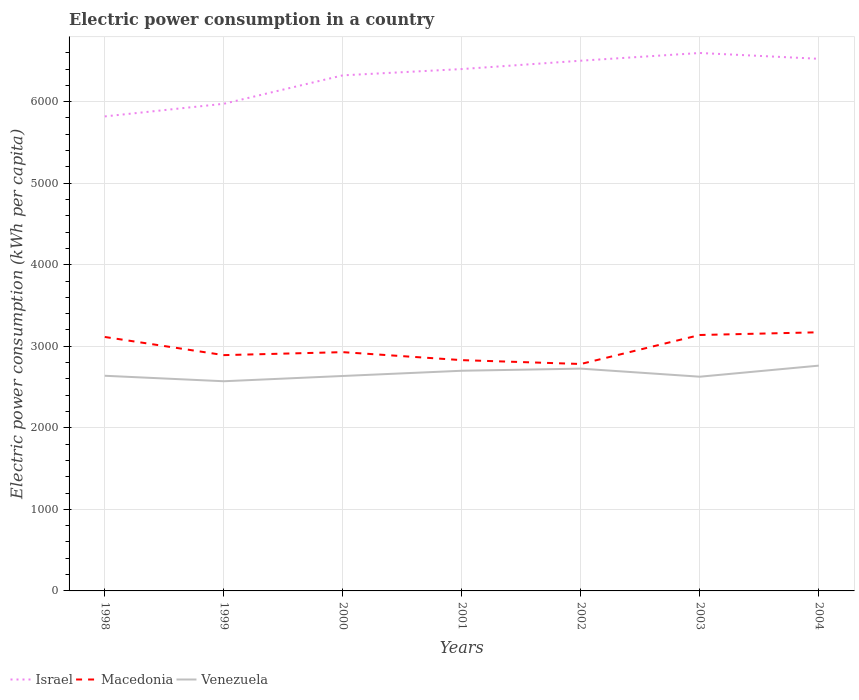How many different coloured lines are there?
Offer a terse response. 3. Is the number of lines equal to the number of legend labels?
Ensure brevity in your answer.  Yes. Across all years, what is the maximum electric power consumption in in Macedonia?
Ensure brevity in your answer.  2783.05. In which year was the electric power consumption in in Venezuela maximum?
Your answer should be very brief. 1999. What is the total electric power consumption in in Israel in the graph?
Provide a succinct answer. -274.2. What is the difference between the highest and the second highest electric power consumption in in Israel?
Make the answer very short. 777.85. What is the difference between the highest and the lowest electric power consumption in in Venezuela?
Your response must be concise. 3. Is the electric power consumption in in Macedonia strictly greater than the electric power consumption in in Venezuela over the years?
Your response must be concise. No. How many years are there in the graph?
Keep it short and to the point. 7. What is the difference between two consecutive major ticks on the Y-axis?
Offer a very short reply. 1000. Are the values on the major ticks of Y-axis written in scientific E-notation?
Provide a succinct answer. No. Does the graph contain any zero values?
Your response must be concise. No. How are the legend labels stacked?
Your answer should be very brief. Horizontal. What is the title of the graph?
Ensure brevity in your answer.  Electric power consumption in a country. What is the label or title of the Y-axis?
Your answer should be very brief. Electric power consumption (kWh per capita). What is the Electric power consumption (kWh per capita) of Israel in 1998?
Your response must be concise. 5819.46. What is the Electric power consumption (kWh per capita) in Macedonia in 1998?
Provide a short and direct response. 3114.54. What is the Electric power consumption (kWh per capita) in Venezuela in 1998?
Your response must be concise. 2638.75. What is the Electric power consumption (kWh per capita) in Israel in 1999?
Provide a succinct answer. 5974.37. What is the Electric power consumption (kWh per capita) of Macedonia in 1999?
Give a very brief answer. 2891.92. What is the Electric power consumption (kWh per capita) of Venezuela in 1999?
Offer a very short reply. 2571.54. What is the Electric power consumption (kWh per capita) of Israel in 2000?
Make the answer very short. 6323.1. What is the Electric power consumption (kWh per capita) of Macedonia in 2000?
Offer a very short reply. 2928.36. What is the Electric power consumption (kWh per capita) in Venezuela in 2000?
Give a very brief answer. 2636.12. What is the Electric power consumption (kWh per capita) of Israel in 2001?
Offer a terse response. 6400.22. What is the Electric power consumption (kWh per capita) in Macedonia in 2001?
Keep it short and to the point. 2830.45. What is the Electric power consumption (kWh per capita) of Venezuela in 2001?
Offer a terse response. 2700.22. What is the Electric power consumption (kWh per capita) in Israel in 2002?
Make the answer very short. 6502.74. What is the Electric power consumption (kWh per capita) of Macedonia in 2002?
Make the answer very short. 2783.05. What is the Electric power consumption (kWh per capita) of Venezuela in 2002?
Ensure brevity in your answer.  2726.12. What is the Electric power consumption (kWh per capita) in Israel in 2003?
Your response must be concise. 6597.31. What is the Electric power consumption (kWh per capita) of Macedonia in 2003?
Provide a succinct answer. 3138.68. What is the Electric power consumption (kWh per capita) of Venezuela in 2003?
Your answer should be compact. 2627.24. What is the Electric power consumption (kWh per capita) of Israel in 2004?
Make the answer very short. 6525.92. What is the Electric power consumption (kWh per capita) in Macedonia in 2004?
Ensure brevity in your answer.  3172.03. What is the Electric power consumption (kWh per capita) of Venezuela in 2004?
Your response must be concise. 2762.93. Across all years, what is the maximum Electric power consumption (kWh per capita) in Israel?
Offer a terse response. 6597.31. Across all years, what is the maximum Electric power consumption (kWh per capita) of Macedonia?
Make the answer very short. 3172.03. Across all years, what is the maximum Electric power consumption (kWh per capita) in Venezuela?
Provide a short and direct response. 2762.93. Across all years, what is the minimum Electric power consumption (kWh per capita) of Israel?
Your response must be concise. 5819.46. Across all years, what is the minimum Electric power consumption (kWh per capita) of Macedonia?
Offer a terse response. 2783.05. Across all years, what is the minimum Electric power consumption (kWh per capita) in Venezuela?
Keep it short and to the point. 2571.54. What is the total Electric power consumption (kWh per capita) of Israel in the graph?
Offer a terse response. 4.41e+04. What is the total Electric power consumption (kWh per capita) in Macedonia in the graph?
Give a very brief answer. 2.09e+04. What is the total Electric power consumption (kWh per capita) of Venezuela in the graph?
Make the answer very short. 1.87e+04. What is the difference between the Electric power consumption (kWh per capita) of Israel in 1998 and that in 1999?
Offer a very short reply. -154.91. What is the difference between the Electric power consumption (kWh per capita) of Macedonia in 1998 and that in 1999?
Give a very brief answer. 222.62. What is the difference between the Electric power consumption (kWh per capita) in Venezuela in 1998 and that in 1999?
Your answer should be very brief. 67.21. What is the difference between the Electric power consumption (kWh per capita) in Israel in 1998 and that in 2000?
Your answer should be very brief. -503.64. What is the difference between the Electric power consumption (kWh per capita) in Macedonia in 1998 and that in 2000?
Provide a short and direct response. 186.18. What is the difference between the Electric power consumption (kWh per capita) in Venezuela in 1998 and that in 2000?
Ensure brevity in your answer.  2.63. What is the difference between the Electric power consumption (kWh per capita) in Israel in 1998 and that in 2001?
Give a very brief answer. -580.76. What is the difference between the Electric power consumption (kWh per capita) in Macedonia in 1998 and that in 2001?
Offer a terse response. 284.09. What is the difference between the Electric power consumption (kWh per capita) of Venezuela in 1998 and that in 2001?
Give a very brief answer. -61.47. What is the difference between the Electric power consumption (kWh per capita) of Israel in 1998 and that in 2002?
Your answer should be compact. -683.28. What is the difference between the Electric power consumption (kWh per capita) in Macedonia in 1998 and that in 2002?
Your answer should be very brief. 331.48. What is the difference between the Electric power consumption (kWh per capita) in Venezuela in 1998 and that in 2002?
Keep it short and to the point. -87.37. What is the difference between the Electric power consumption (kWh per capita) in Israel in 1998 and that in 2003?
Offer a very short reply. -777.85. What is the difference between the Electric power consumption (kWh per capita) in Macedonia in 1998 and that in 2003?
Your answer should be very brief. -24.14. What is the difference between the Electric power consumption (kWh per capita) in Venezuela in 1998 and that in 2003?
Ensure brevity in your answer.  11.51. What is the difference between the Electric power consumption (kWh per capita) in Israel in 1998 and that in 2004?
Provide a succinct answer. -706.46. What is the difference between the Electric power consumption (kWh per capita) in Macedonia in 1998 and that in 2004?
Provide a short and direct response. -57.49. What is the difference between the Electric power consumption (kWh per capita) of Venezuela in 1998 and that in 2004?
Ensure brevity in your answer.  -124.18. What is the difference between the Electric power consumption (kWh per capita) of Israel in 1999 and that in 2000?
Your response must be concise. -348.74. What is the difference between the Electric power consumption (kWh per capita) in Macedonia in 1999 and that in 2000?
Your answer should be compact. -36.43. What is the difference between the Electric power consumption (kWh per capita) in Venezuela in 1999 and that in 2000?
Ensure brevity in your answer.  -64.58. What is the difference between the Electric power consumption (kWh per capita) in Israel in 1999 and that in 2001?
Keep it short and to the point. -425.85. What is the difference between the Electric power consumption (kWh per capita) of Macedonia in 1999 and that in 2001?
Your answer should be very brief. 61.47. What is the difference between the Electric power consumption (kWh per capita) in Venezuela in 1999 and that in 2001?
Offer a very short reply. -128.68. What is the difference between the Electric power consumption (kWh per capita) of Israel in 1999 and that in 2002?
Provide a short and direct response. -528.37. What is the difference between the Electric power consumption (kWh per capita) of Macedonia in 1999 and that in 2002?
Give a very brief answer. 108.87. What is the difference between the Electric power consumption (kWh per capita) of Venezuela in 1999 and that in 2002?
Your response must be concise. -154.58. What is the difference between the Electric power consumption (kWh per capita) of Israel in 1999 and that in 2003?
Provide a short and direct response. -622.94. What is the difference between the Electric power consumption (kWh per capita) of Macedonia in 1999 and that in 2003?
Your answer should be very brief. -246.76. What is the difference between the Electric power consumption (kWh per capita) of Venezuela in 1999 and that in 2003?
Provide a succinct answer. -55.7. What is the difference between the Electric power consumption (kWh per capita) in Israel in 1999 and that in 2004?
Ensure brevity in your answer.  -551.55. What is the difference between the Electric power consumption (kWh per capita) in Macedonia in 1999 and that in 2004?
Offer a very short reply. -280.1. What is the difference between the Electric power consumption (kWh per capita) of Venezuela in 1999 and that in 2004?
Give a very brief answer. -191.39. What is the difference between the Electric power consumption (kWh per capita) of Israel in 2000 and that in 2001?
Make the answer very short. -77.11. What is the difference between the Electric power consumption (kWh per capita) in Macedonia in 2000 and that in 2001?
Make the answer very short. 97.9. What is the difference between the Electric power consumption (kWh per capita) in Venezuela in 2000 and that in 2001?
Make the answer very short. -64.1. What is the difference between the Electric power consumption (kWh per capita) in Israel in 2000 and that in 2002?
Make the answer very short. -179.64. What is the difference between the Electric power consumption (kWh per capita) of Macedonia in 2000 and that in 2002?
Keep it short and to the point. 145.3. What is the difference between the Electric power consumption (kWh per capita) in Venezuela in 2000 and that in 2002?
Keep it short and to the point. -90. What is the difference between the Electric power consumption (kWh per capita) of Israel in 2000 and that in 2003?
Ensure brevity in your answer.  -274.2. What is the difference between the Electric power consumption (kWh per capita) in Macedonia in 2000 and that in 2003?
Offer a terse response. -210.33. What is the difference between the Electric power consumption (kWh per capita) in Venezuela in 2000 and that in 2003?
Your answer should be very brief. 8.88. What is the difference between the Electric power consumption (kWh per capita) of Israel in 2000 and that in 2004?
Offer a very short reply. -202.82. What is the difference between the Electric power consumption (kWh per capita) in Macedonia in 2000 and that in 2004?
Give a very brief answer. -243.67. What is the difference between the Electric power consumption (kWh per capita) in Venezuela in 2000 and that in 2004?
Your response must be concise. -126.81. What is the difference between the Electric power consumption (kWh per capita) of Israel in 2001 and that in 2002?
Your answer should be very brief. -102.52. What is the difference between the Electric power consumption (kWh per capita) of Macedonia in 2001 and that in 2002?
Offer a terse response. 47.4. What is the difference between the Electric power consumption (kWh per capita) in Venezuela in 2001 and that in 2002?
Your answer should be very brief. -25.9. What is the difference between the Electric power consumption (kWh per capita) in Israel in 2001 and that in 2003?
Your answer should be compact. -197.09. What is the difference between the Electric power consumption (kWh per capita) of Macedonia in 2001 and that in 2003?
Offer a very short reply. -308.23. What is the difference between the Electric power consumption (kWh per capita) of Venezuela in 2001 and that in 2003?
Your response must be concise. 72.98. What is the difference between the Electric power consumption (kWh per capita) of Israel in 2001 and that in 2004?
Make the answer very short. -125.7. What is the difference between the Electric power consumption (kWh per capita) of Macedonia in 2001 and that in 2004?
Ensure brevity in your answer.  -341.57. What is the difference between the Electric power consumption (kWh per capita) of Venezuela in 2001 and that in 2004?
Ensure brevity in your answer.  -62.71. What is the difference between the Electric power consumption (kWh per capita) in Israel in 2002 and that in 2003?
Give a very brief answer. -94.57. What is the difference between the Electric power consumption (kWh per capita) in Macedonia in 2002 and that in 2003?
Offer a terse response. -355.63. What is the difference between the Electric power consumption (kWh per capita) of Venezuela in 2002 and that in 2003?
Offer a very short reply. 98.88. What is the difference between the Electric power consumption (kWh per capita) of Israel in 2002 and that in 2004?
Provide a short and direct response. -23.18. What is the difference between the Electric power consumption (kWh per capita) in Macedonia in 2002 and that in 2004?
Your answer should be very brief. -388.97. What is the difference between the Electric power consumption (kWh per capita) in Venezuela in 2002 and that in 2004?
Give a very brief answer. -36.81. What is the difference between the Electric power consumption (kWh per capita) of Israel in 2003 and that in 2004?
Give a very brief answer. 71.38. What is the difference between the Electric power consumption (kWh per capita) in Macedonia in 2003 and that in 2004?
Ensure brevity in your answer.  -33.34. What is the difference between the Electric power consumption (kWh per capita) in Venezuela in 2003 and that in 2004?
Make the answer very short. -135.69. What is the difference between the Electric power consumption (kWh per capita) of Israel in 1998 and the Electric power consumption (kWh per capita) of Macedonia in 1999?
Provide a short and direct response. 2927.54. What is the difference between the Electric power consumption (kWh per capita) in Israel in 1998 and the Electric power consumption (kWh per capita) in Venezuela in 1999?
Your response must be concise. 3247.92. What is the difference between the Electric power consumption (kWh per capita) in Macedonia in 1998 and the Electric power consumption (kWh per capita) in Venezuela in 1999?
Your answer should be compact. 543. What is the difference between the Electric power consumption (kWh per capita) of Israel in 1998 and the Electric power consumption (kWh per capita) of Macedonia in 2000?
Make the answer very short. 2891.11. What is the difference between the Electric power consumption (kWh per capita) in Israel in 1998 and the Electric power consumption (kWh per capita) in Venezuela in 2000?
Your answer should be compact. 3183.35. What is the difference between the Electric power consumption (kWh per capita) of Macedonia in 1998 and the Electric power consumption (kWh per capita) of Venezuela in 2000?
Provide a succinct answer. 478.42. What is the difference between the Electric power consumption (kWh per capita) in Israel in 1998 and the Electric power consumption (kWh per capita) in Macedonia in 2001?
Make the answer very short. 2989.01. What is the difference between the Electric power consumption (kWh per capita) of Israel in 1998 and the Electric power consumption (kWh per capita) of Venezuela in 2001?
Offer a very short reply. 3119.24. What is the difference between the Electric power consumption (kWh per capita) of Macedonia in 1998 and the Electric power consumption (kWh per capita) of Venezuela in 2001?
Ensure brevity in your answer.  414.32. What is the difference between the Electric power consumption (kWh per capita) in Israel in 1998 and the Electric power consumption (kWh per capita) in Macedonia in 2002?
Your answer should be very brief. 3036.41. What is the difference between the Electric power consumption (kWh per capita) in Israel in 1998 and the Electric power consumption (kWh per capita) in Venezuela in 2002?
Offer a very short reply. 3093.35. What is the difference between the Electric power consumption (kWh per capita) of Macedonia in 1998 and the Electric power consumption (kWh per capita) of Venezuela in 2002?
Your answer should be compact. 388.42. What is the difference between the Electric power consumption (kWh per capita) in Israel in 1998 and the Electric power consumption (kWh per capita) in Macedonia in 2003?
Provide a short and direct response. 2680.78. What is the difference between the Electric power consumption (kWh per capita) in Israel in 1998 and the Electric power consumption (kWh per capita) in Venezuela in 2003?
Ensure brevity in your answer.  3192.22. What is the difference between the Electric power consumption (kWh per capita) in Macedonia in 1998 and the Electric power consumption (kWh per capita) in Venezuela in 2003?
Provide a short and direct response. 487.3. What is the difference between the Electric power consumption (kWh per capita) of Israel in 1998 and the Electric power consumption (kWh per capita) of Macedonia in 2004?
Your response must be concise. 2647.43. What is the difference between the Electric power consumption (kWh per capita) of Israel in 1998 and the Electric power consumption (kWh per capita) of Venezuela in 2004?
Provide a short and direct response. 3056.53. What is the difference between the Electric power consumption (kWh per capita) of Macedonia in 1998 and the Electric power consumption (kWh per capita) of Venezuela in 2004?
Ensure brevity in your answer.  351.61. What is the difference between the Electric power consumption (kWh per capita) of Israel in 1999 and the Electric power consumption (kWh per capita) of Macedonia in 2000?
Make the answer very short. 3046.01. What is the difference between the Electric power consumption (kWh per capita) in Israel in 1999 and the Electric power consumption (kWh per capita) in Venezuela in 2000?
Offer a very short reply. 3338.25. What is the difference between the Electric power consumption (kWh per capita) of Macedonia in 1999 and the Electric power consumption (kWh per capita) of Venezuela in 2000?
Provide a short and direct response. 255.81. What is the difference between the Electric power consumption (kWh per capita) in Israel in 1999 and the Electric power consumption (kWh per capita) in Macedonia in 2001?
Provide a succinct answer. 3143.91. What is the difference between the Electric power consumption (kWh per capita) in Israel in 1999 and the Electric power consumption (kWh per capita) in Venezuela in 2001?
Keep it short and to the point. 3274.15. What is the difference between the Electric power consumption (kWh per capita) in Macedonia in 1999 and the Electric power consumption (kWh per capita) in Venezuela in 2001?
Offer a very short reply. 191.71. What is the difference between the Electric power consumption (kWh per capita) of Israel in 1999 and the Electric power consumption (kWh per capita) of Macedonia in 2002?
Ensure brevity in your answer.  3191.31. What is the difference between the Electric power consumption (kWh per capita) of Israel in 1999 and the Electric power consumption (kWh per capita) of Venezuela in 2002?
Provide a short and direct response. 3248.25. What is the difference between the Electric power consumption (kWh per capita) in Macedonia in 1999 and the Electric power consumption (kWh per capita) in Venezuela in 2002?
Offer a very short reply. 165.81. What is the difference between the Electric power consumption (kWh per capita) in Israel in 1999 and the Electric power consumption (kWh per capita) in Macedonia in 2003?
Your answer should be compact. 2835.68. What is the difference between the Electric power consumption (kWh per capita) of Israel in 1999 and the Electric power consumption (kWh per capita) of Venezuela in 2003?
Ensure brevity in your answer.  3347.13. What is the difference between the Electric power consumption (kWh per capita) in Macedonia in 1999 and the Electric power consumption (kWh per capita) in Venezuela in 2003?
Ensure brevity in your answer.  264.68. What is the difference between the Electric power consumption (kWh per capita) in Israel in 1999 and the Electric power consumption (kWh per capita) in Macedonia in 2004?
Keep it short and to the point. 2802.34. What is the difference between the Electric power consumption (kWh per capita) in Israel in 1999 and the Electric power consumption (kWh per capita) in Venezuela in 2004?
Ensure brevity in your answer.  3211.44. What is the difference between the Electric power consumption (kWh per capita) of Macedonia in 1999 and the Electric power consumption (kWh per capita) of Venezuela in 2004?
Your response must be concise. 129. What is the difference between the Electric power consumption (kWh per capita) in Israel in 2000 and the Electric power consumption (kWh per capita) in Macedonia in 2001?
Keep it short and to the point. 3492.65. What is the difference between the Electric power consumption (kWh per capita) of Israel in 2000 and the Electric power consumption (kWh per capita) of Venezuela in 2001?
Make the answer very short. 3622.89. What is the difference between the Electric power consumption (kWh per capita) of Macedonia in 2000 and the Electric power consumption (kWh per capita) of Venezuela in 2001?
Offer a terse response. 228.14. What is the difference between the Electric power consumption (kWh per capita) in Israel in 2000 and the Electric power consumption (kWh per capita) in Macedonia in 2002?
Your answer should be very brief. 3540.05. What is the difference between the Electric power consumption (kWh per capita) of Israel in 2000 and the Electric power consumption (kWh per capita) of Venezuela in 2002?
Provide a succinct answer. 3596.99. What is the difference between the Electric power consumption (kWh per capita) in Macedonia in 2000 and the Electric power consumption (kWh per capita) in Venezuela in 2002?
Keep it short and to the point. 202.24. What is the difference between the Electric power consumption (kWh per capita) in Israel in 2000 and the Electric power consumption (kWh per capita) in Macedonia in 2003?
Provide a succinct answer. 3184.42. What is the difference between the Electric power consumption (kWh per capita) of Israel in 2000 and the Electric power consumption (kWh per capita) of Venezuela in 2003?
Keep it short and to the point. 3695.86. What is the difference between the Electric power consumption (kWh per capita) of Macedonia in 2000 and the Electric power consumption (kWh per capita) of Venezuela in 2003?
Offer a terse response. 301.12. What is the difference between the Electric power consumption (kWh per capita) of Israel in 2000 and the Electric power consumption (kWh per capita) of Macedonia in 2004?
Keep it short and to the point. 3151.08. What is the difference between the Electric power consumption (kWh per capita) in Israel in 2000 and the Electric power consumption (kWh per capita) in Venezuela in 2004?
Your response must be concise. 3560.18. What is the difference between the Electric power consumption (kWh per capita) in Macedonia in 2000 and the Electric power consumption (kWh per capita) in Venezuela in 2004?
Your answer should be very brief. 165.43. What is the difference between the Electric power consumption (kWh per capita) in Israel in 2001 and the Electric power consumption (kWh per capita) in Macedonia in 2002?
Give a very brief answer. 3617.16. What is the difference between the Electric power consumption (kWh per capita) in Israel in 2001 and the Electric power consumption (kWh per capita) in Venezuela in 2002?
Your answer should be very brief. 3674.1. What is the difference between the Electric power consumption (kWh per capita) in Macedonia in 2001 and the Electric power consumption (kWh per capita) in Venezuela in 2002?
Make the answer very short. 104.34. What is the difference between the Electric power consumption (kWh per capita) in Israel in 2001 and the Electric power consumption (kWh per capita) in Macedonia in 2003?
Provide a short and direct response. 3261.53. What is the difference between the Electric power consumption (kWh per capita) in Israel in 2001 and the Electric power consumption (kWh per capita) in Venezuela in 2003?
Your answer should be compact. 3772.98. What is the difference between the Electric power consumption (kWh per capita) in Macedonia in 2001 and the Electric power consumption (kWh per capita) in Venezuela in 2003?
Offer a very short reply. 203.21. What is the difference between the Electric power consumption (kWh per capita) of Israel in 2001 and the Electric power consumption (kWh per capita) of Macedonia in 2004?
Make the answer very short. 3228.19. What is the difference between the Electric power consumption (kWh per capita) of Israel in 2001 and the Electric power consumption (kWh per capita) of Venezuela in 2004?
Your answer should be very brief. 3637.29. What is the difference between the Electric power consumption (kWh per capita) of Macedonia in 2001 and the Electric power consumption (kWh per capita) of Venezuela in 2004?
Give a very brief answer. 67.53. What is the difference between the Electric power consumption (kWh per capita) of Israel in 2002 and the Electric power consumption (kWh per capita) of Macedonia in 2003?
Make the answer very short. 3364.06. What is the difference between the Electric power consumption (kWh per capita) in Israel in 2002 and the Electric power consumption (kWh per capita) in Venezuela in 2003?
Ensure brevity in your answer.  3875.5. What is the difference between the Electric power consumption (kWh per capita) in Macedonia in 2002 and the Electric power consumption (kWh per capita) in Venezuela in 2003?
Ensure brevity in your answer.  155.81. What is the difference between the Electric power consumption (kWh per capita) in Israel in 2002 and the Electric power consumption (kWh per capita) in Macedonia in 2004?
Your response must be concise. 3330.71. What is the difference between the Electric power consumption (kWh per capita) of Israel in 2002 and the Electric power consumption (kWh per capita) of Venezuela in 2004?
Make the answer very short. 3739.81. What is the difference between the Electric power consumption (kWh per capita) in Macedonia in 2002 and the Electric power consumption (kWh per capita) in Venezuela in 2004?
Keep it short and to the point. 20.13. What is the difference between the Electric power consumption (kWh per capita) of Israel in 2003 and the Electric power consumption (kWh per capita) of Macedonia in 2004?
Provide a short and direct response. 3425.28. What is the difference between the Electric power consumption (kWh per capita) of Israel in 2003 and the Electric power consumption (kWh per capita) of Venezuela in 2004?
Provide a succinct answer. 3834.38. What is the difference between the Electric power consumption (kWh per capita) in Macedonia in 2003 and the Electric power consumption (kWh per capita) in Venezuela in 2004?
Keep it short and to the point. 375.76. What is the average Electric power consumption (kWh per capita) of Israel per year?
Provide a short and direct response. 6306.16. What is the average Electric power consumption (kWh per capita) of Macedonia per year?
Provide a short and direct response. 2979.86. What is the average Electric power consumption (kWh per capita) of Venezuela per year?
Your answer should be very brief. 2666.13. In the year 1998, what is the difference between the Electric power consumption (kWh per capita) in Israel and Electric power consumption (kWh per capita) in Macedonia?
Provide a succinct answer. 2704.92. In the year 1998, what is the difference between the Electric power consumption (kWh per capita) of Israel and Electric power consumption (kWh per capita) of Venezuela?
Make the answer very short. 3180.71. In the year 1998, what is the difference between the Electric power consumption (kWh per capita) of Macedonia and Electric power consumption (kWh per capita) of Venezuela?
Offer a very short reply. 475.79. In the year 1999, what is the difference between the Electric power consumption (kWh per capita) of Israel and Electric power consumption (kWh per capita) of Macedonia?
Offer a terse response. 3082.44. In the year 1999, what is the difference between the Electric power consumption (kWh per capita) in Israel and Electric power consumption (kWh per capita) in Venezuela?
Your answer should be very brief. 3402.83. In the year 1999, what is the difference between the Electric power consumption (kWh per capita) in Macedonia and Electric power consumption (kWh per capita) in Venezuela?
Your answer should be compact. 320.38. In the year 2000, what is the difference between the Electric power consumption (kWh per capita) in Israel and Electric power consumption (kWh per capita) in Macedonia?
Keep it short and to the point. 3394.75. In the year 2000, what is the difference between the Electric power consumption (kWh per capita) of Israel and Electric power consumption (kWh per capita) of Venezuela?
Keep it short and to the point. 3686.99. In the year 2000, what is the difference between the Electric power consumption (kWh per capita) in Macedonia and Electric power consumption (kWh per capita) in Venezuela?
Make the answer very short. 292.24. In the year 2001, what is the difference between the Electric power consumption (kWh per capita) in Israel and Electric power consumption (kWh per capita) in Macedonia?
Offer a very short reply. 3569.77. In the year 2001, what is the difference between the Electric power consumption (kWh per capita) of Israel and Electric power consumption (kWh per capita) of Venezuela?
Ensure brevity in your answer.  3700. In the year 2001, what is the difference between the Electric power consumption (kWh per capita) in Macedonia and Electric power consumption (kWh per capita) in Venezuela?
Keep it short and to the point. 130.24. In the year 2002, what is the difference between the Electric power consumption (kWh per capita) of Israel and Electric power consumption (kWh per capita) of Macedonia?
Keep it short and to the point. 3719.68. In the year 2002, what is the difference between the Electric power consumption (kWh per capita) in Israel and Electric power consumption (kWh per capita) in Venezuela?
Give a very brief answer. 3776.62. In the year 2002, what is the difference between the Electric power consumption (kWh per capita) in Macedonia and Electric power consumption (kWh per capita) in Venezuela?
Give a very brief answer. 56.94. In the year 2003, what is the difference between the Electric power consumption (kWh per capita) in Israel and Electric power consumption (kWh per capita) in Macedonia?
Offer a very short reply. 3458.62. In the year 2003, what is the difference between the Electric power consumption (kWh per capita) of Israel and Electric power consumption (kWh per capita) of Venezuela?
Ensure brevity in your answer.  3970.07. In the year 2003, what is the difference between the Electric power consumption (kWh per capita) in Macedonia and Electric power consumption (kWh per capita) in Venezuela?
Provide a short and direct response. 511.44. In the year 2004, what is the difference between the Electric power consumption (kWh per capita) of Israel and Electric power consumption (kWh per capita) of Macedonia?
Your response must be concise. 3353.89. In the year 2004, what is the difference between the Electric power consumption (kWh per capita) of Israel and Electric power consumption (kWh per capita) of Venezuela?
Make the answer very short. 3762.99. In the year 2004, what is the difference between the Electric power consumption (kWh per capita) of Macedonia and Electric power consumption (kWh per capita) of Venezuela?
Ensure brevity in your answer.  409.1. What is the ratio of the Electric power consumption (kWh per capita) of Israel in 1998 to that in 1999?
Make the answer very short. 0.97. What is the ratio of the Electric power consumption (kWh per capita) in Macedonia in 1998 to that in 1999?
Keep it short and to the point. 1.08. What is the ratio of the Electric power consumption (kWh per capita) of Venezuela in 1998 to that in 1999?
Your response must be concise. 1.03. What is the ratio of the Electric power consumption (kWh per capita) in Israel in 1998 to that in 2000?
Provide a short and direct response. 0.92. What is the ratio of the Electric power consumption (kWh per capita) of Macedonia in 1998 to that in 2000?
Your answer should be compact. 1.06. What is the ratio of the Electric power consumption (kWh per capita) of Israel in 1998 to that in 2001?
Provide a short and direct response. 0.91. What is the ratio of the Electric power consumption (kWh per capita) of Macedonia in 1998 to that in 2001?
Keep it short and to the point. 1.1. What is the ratio of the Electric power consumption (kWh per capita) in Venezuela in 1998 to that in 2001?
Offer a very short reply. 0.98. What is the ratio of the Electric power consumption (kWh per capita) in Israel in 1998 to that in 2002?
Your answer should be very brief. 0.89. What is the ratio of the Electric power consumption (kWh per capita) in Macedonia in 1998 to that in 2002?
Ensure brevity in your answer.  1.12. What is the ratio of the Electric power consumption (kWh per capita) of Venezuela in 1998 to that in 2002?
Your answer should be very brief. 0.97. What is the ratio of the Electric power consumption (kWh per capita) of Israel in 1998 to that in 2003?
Make the answer very short. 0.88. What is the ratio of the Electric power consumption (kWh per capita) in Venezuela in 1998 to that in 2003?
Your response must be concise. 1. What is the ratio of the Electric power consumption (kWh per capita) in Israel in 1998 to that in 2004?
Keep it short and to the point. 0.89. What is the ratio of the Electric power consumption (kWh per capita) in Macedonia in 1998 to that in 2004?
Ensure brevity in your answer.  0.98. What is the ratio of the Electric power consumption (kWh per capita) in Venezuela in 1998 to that in 2004?
Your answer should be very brief. 0.96. What is the ratio of the Electric power consumption (kWh per capita) in Israel in 1999 to that in 2000?
Make the answer very short. 0.94. What is the ratio of the Electric power consumption (kWh per capita) of Macedonia in 1999 to that in 2000?
Your response must be concise. 0.99. What is the ratio of the Electric power consumption (kWh per capita) of Venezuela in 1999 to that in 2000?
Offer a terse response. 0.98. What is the ratio of the Electric power consumption (kWh per capita) in Israel in 1999 to that in 2001?
Offer a terse response. 0.93. What is the ratio of the Electric power consumption (kWh per capita) of Macedonia in 1999 to that in 2001?
Provide a succinct answer. 1.02. What is the ratio of the Electric power consumption (kWh per capita) in Venezuela in 1999 to that in 2001?
Make the answer very short. 0.95. What is the ratio of the Electric power consumption (kWh per capita) in Israel in 1999 to that in 2002?
Keep it short and to the point. 0.92. What is the ratio of the Electric power consumption (kWh per capita) in Macedonia in 1999 to that in 2002?
Your answer should be compact. 1.04. What is the ratio of the Electric power consumption (kWh per capita) of Venezuela in 1999 to that in 2002?
Provide a short and direct response. 0.94. What is the ratio of the Electric power consumption (kWh per capita) of Israel in 1999 to that in 2003?
Provide a succinct answer. 0.91. What is the ratio of the Electric power consumption (kWh per capita) in Macedonia in 1999 to that in 2003?
Offer a very short reply. 0.92. What is the ratio of the Electric power consumption (kWh per capita) of Venezuela in 1999 to that in 2003?
Your response must be concise. 0.98. What is the ratio of the Electric power consumption (kWh per capita) of Israel in 1999 to that in 2004?
Your answer should be compact. 0.92. What is the ratio of the Electric power consumption (kWh per capita) of Macedonia in 1999 to that in 2004?
Your answer should be very brief. 0.91. What is the ratio of the Electric power consumption (kWh per capita) of Venezuela in 1999 to that in 2004?
Ensure brevity in your answer.  0.93. What is the ratio of the Electric power consumption (kWh per capita) of Macedonia in 2000 to that in 2001?
Offer a very short reply. 1.03. What is the ratio of the Electric power consumption (kWh per capita) in Venezuela in 2000 to that in 2001?
Offer a very short reply. 0.98. What is the ratio of the Electric power consumption (kWh per capita) in Israel in 2000 to that in 2002?
Make the answer very short. 0.97. What is the ratio of the Electric power consumption (kWh per capita) of Macedonia in 2000 to that in 2002?
Provide a succinct answer. 1.05. What is the ratio of the Electric power consumption (kWh per capita) of Israel in 2000 to that in 2003?
Offer a terse response. 0.96. What is the ratio of the Electric power consumption (kWh per capita) in Macedonia in 2000 to that in 2003?
Provide a succinct answer. 0.93. What is the ratio of the Electric power consumption (kWh per capita) in Israel in 2000 to that in 2004?
Give a very brief answer. 0.97. What is the ratio of the Electric power consumption (kWh per capita) of Macedonia in 2000 to that in 2004?
Make the answer very short. 0.92. What is the ratio of the Electric power consumption (kWh per capita) of Venezuela in 2000 to that in 2004?
Give a very brief answer. 0.95. What is the ratio of the Electric power consumption (kWh per capita) in Israel in 2001 to that in 2002?
Your response must be concise. 0.98. What is the ratio of the Electric power consumption (kWh per capita) in Israel in 2001 to that in 2003?
Offer a terse response. 0.97. What is the ratio of the Electric power consumption (kWh per capita) in Macedonia in 2001 to that in 2003?
Your response must be concise. 0.9. What is the ratio of the Electric power consumption (kWh per capita) in Venezuela in 2001 to that in 2003?
Your answer should be very brief. 1.03. What is the ratio of the Electric power consumption (kWh per capita) in Israel in 2001 to that in 2004?
Your answer should be very brief. 0.98. What is the ratio of the Electric power consumption (kWh per capita) of Macedonia in 2001 to that in 2004?
Ensure brevity in your answer.  0.89. What is the ratio of the Electric power consumption (kWh per capita) in Venezuela in 2001 to that in 2004?
Keep it short and to the point. 0.98. What is the ratio of the Electric power consumption (kWh per capita) of Israel in 2002 to that in 2003?
Offer a terse response. 0.99. What is the ratio of the Electric power consumption (kWh per capita) in Macedonia in 2002 to that in 2003?
Your response must be concise. 0.89. What is the ratio of the Electric power consumption (kWh per capita) in Venezuela in 2002 to that in 2003?
Provide a short and direct response. 1.04. What is the ratio of the Electric power consumption (kWh per capita) in Macedonia in 2002 to that in 2004?
Offer a terse response. 0.88. What is the ratio of the Electric power consumption (kWh per capita) in Venezuela in 2002 to that in 2004?
Your answer should be very brief. 0.99. What is the ratio of the Electric power consumption (kWh per capita) in Israel in 2003 to that in 2004?
Make the answer very short. 1.01. What is the ratio of the Electric power consumption (kWh per capita) of Macedonia in 2003 to that in 2004?
Make the answer very short. 0.99. What is the ratio of the Electric power consumption (kWh per capita) in Venezuela in 2003 to that in 2004?
Offer a very short reply. 0.95. What is the difference between the highest and the second highest Electric power consumption (kWh per capita) of Israel?
Make the answer very short. 71.38. What is the difference between the highest and the second highest Electric power consumption (kWh per capita) of Macedonia?
Make the answer very short. 33.34. What is the difference between the highest and the second highest Electric power consumption (kWh per capita) of Venezuela?
Your response must be concise. 36.81. What is the difference between the highest and the lowest Electric power consumption (kWh per capita) of Israel?
Give a very brief answer. 777.85. What is the difference between the highest and the lowest Electric power consumption (kWh per capita) of Macedonia?
Offer a very short reply. 388.97. What is the difference between the highest and the lowest Electric power consumption (kWh per capita) in Venezuela?
Provide a short and direct response. 191.39. 